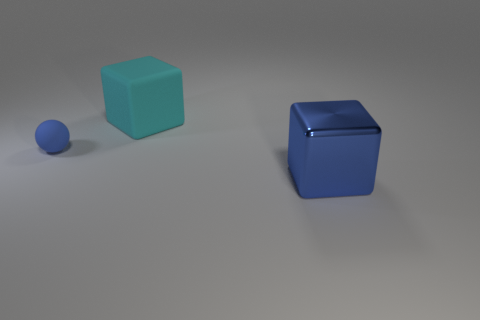Add 1 blue cubes. How many objects exist? 4 Subtract 1 cyan blocks. How many objects are left? 2 Subtract all spheres. How many objects are left? 2 Subtract all red blocks. Subtract all brown spheres. How many blocks are left? 2 Subtract all blue metallic objects. Subtract all big gray metal blocks. How many objects are left? 2 Add 3 big cyan cubes. How many big cyan cubes are left? 4 Add 3 tiny brown shiny blocks. How many tiny brown shiny blocks exist? 3 